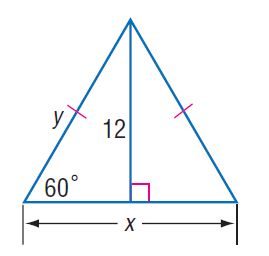Question: Find x.
Choices:
A. 6
B. 4 \sqrt { 3 }
C. 12
D. 8 \sqrt { 3 }
Answer with the letter. Answer: D Question: Find y.
Choices:
A. 4 \sqrt { 3 }
B. 8
C. 8 \sqrt { 3 }
D. 16
Answer with the letter. Answer: C 